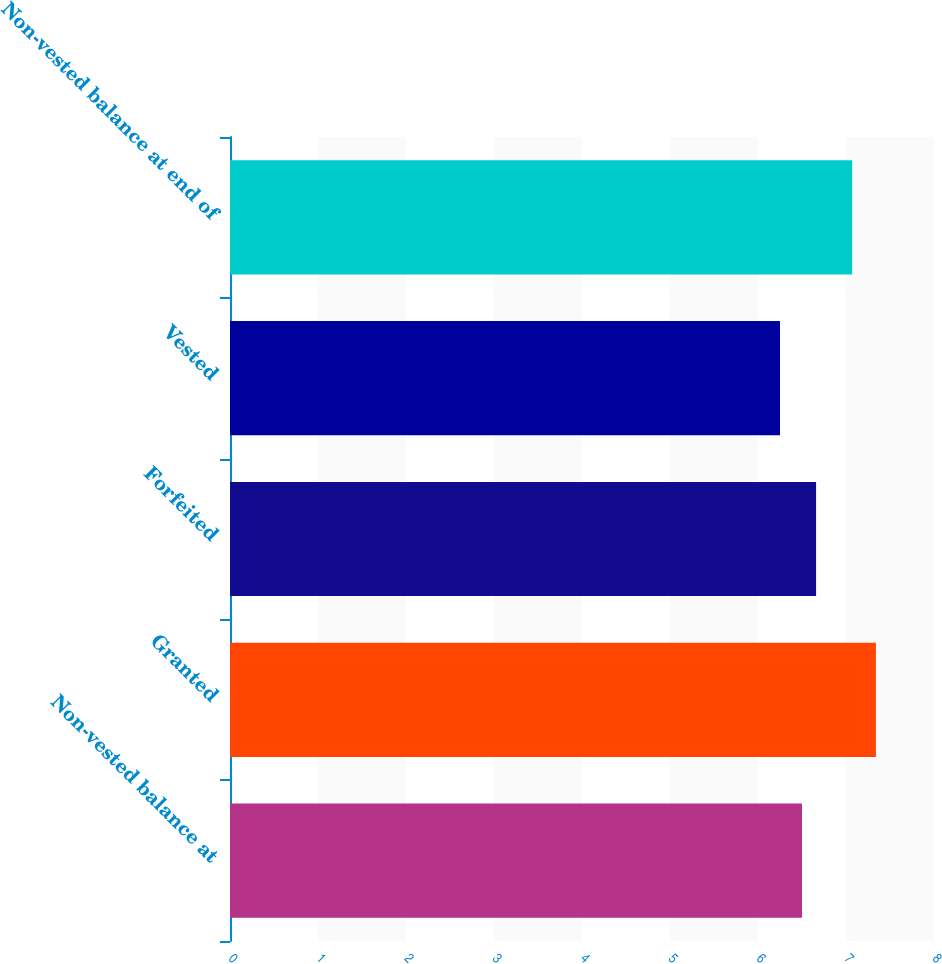<chart> <loc_0><loc_0><loc_500><loc_500><bar_chart><fcel>Non-vested balance at<fcel>Granted<fcel>Forfeited<fcel>Vested<fcel>Non-vested balance at end of<nl><fcel>6.5<fcel>7.34<fcel>6.66<fcel>6.25<fcel>7.07<nl></chart> 